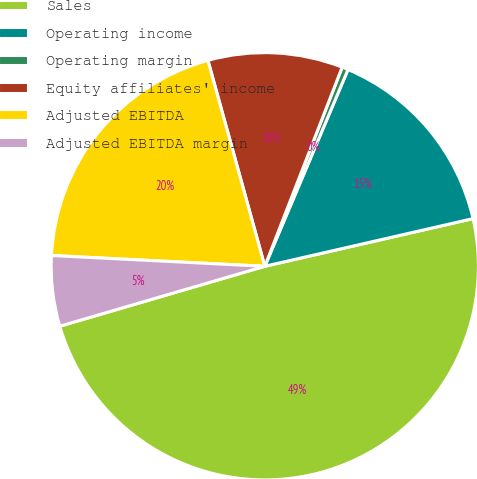Convert chart to OTSL. <chart><loc_0><loc_0><loc_500><loc_500><pie_chart><fcel>Sales<fcel>Operating income<fcel>Operating margin<fcel>Equity affiliates' income<fcel>Adjusted EBITDA<fcel>Adjusted EBITDA margin<nl><fcel>49.06%<fcel>15.05%<fcel>0.47%<fcel>10.19%<fcel>19.91%<fcel>5.33%<nl></chart> 